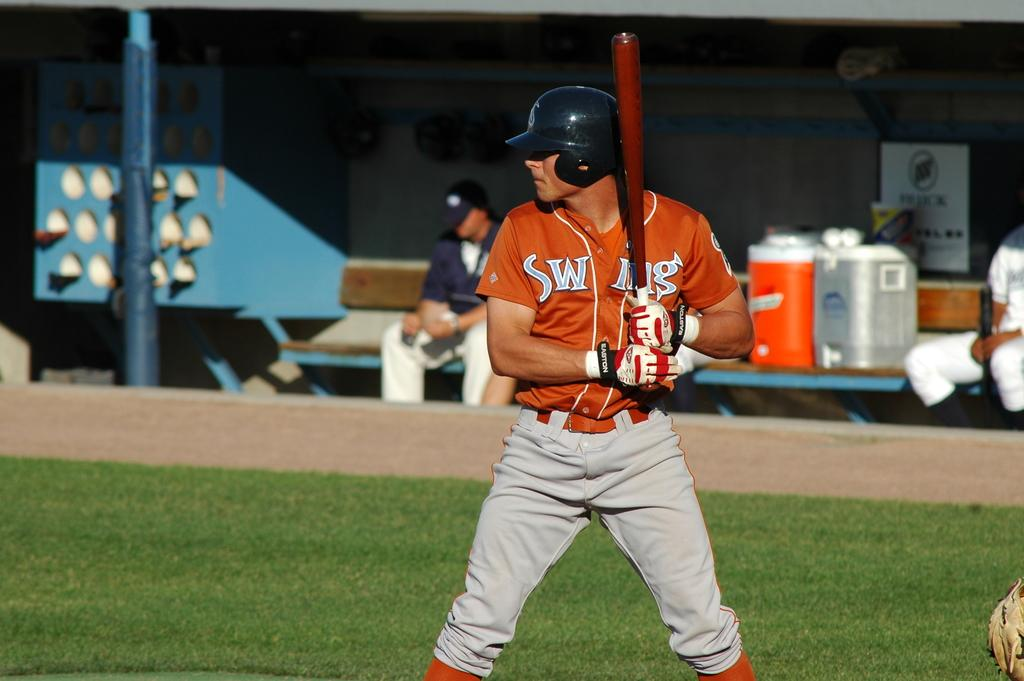<image>
Describe the image concisely. The baseball player at bat is wearing gloves made by Easton. 